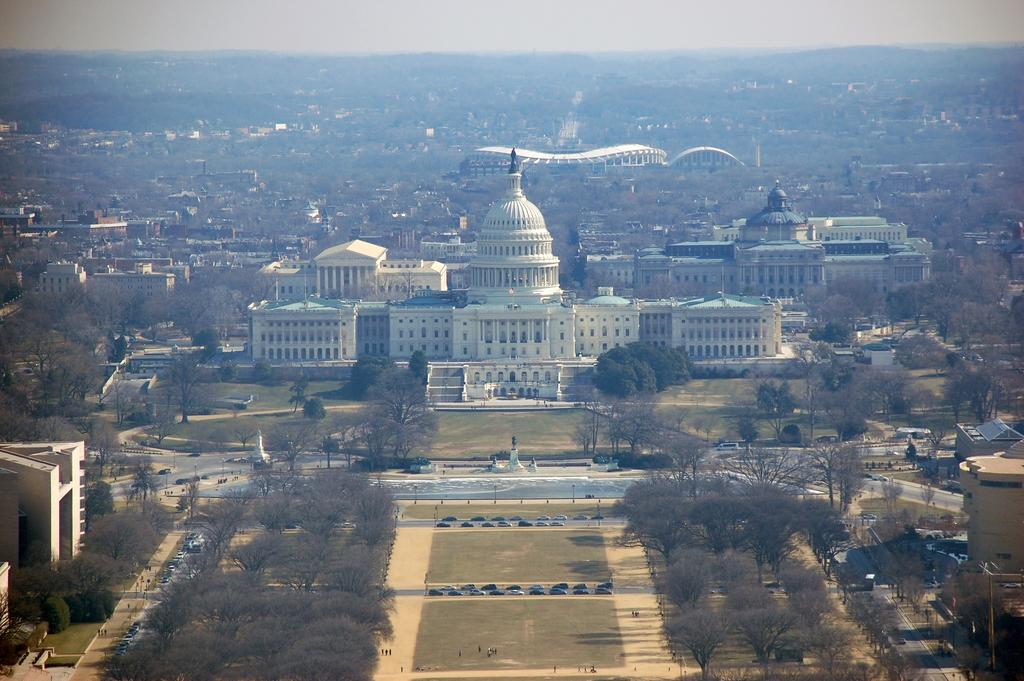What type of scene is depicted in the image? The image is an overview of a city. What structures can be seen in the city? There are buildings in the image. What natural elements are present in the city? There are trees in the image. How are the buildings and trees connected in the city? There are roads in the image that connect the buildings and trees. What vehicles are parked along the roads? Cars are parked on the roads in the image. Can you see any snails crawling on the trees in the image? There are no snails visible in the image; it only shows a city overview with buildings, trees, roads, and parked cars. 